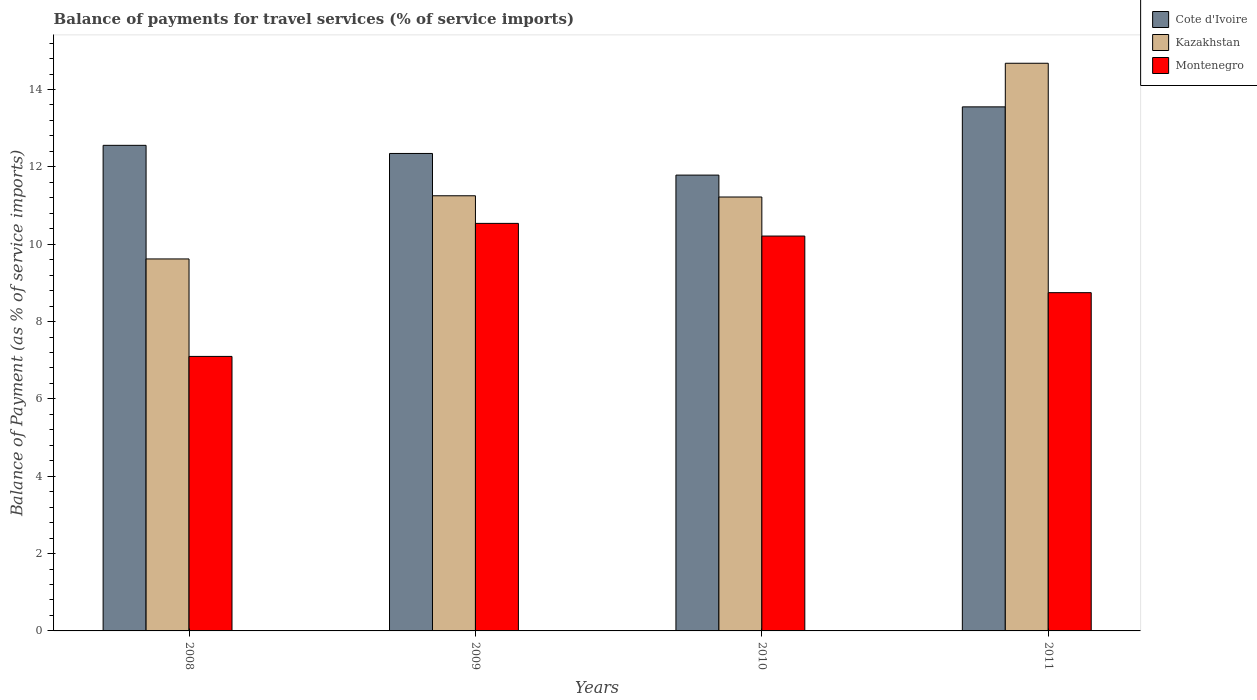How many different coloured bars are there?
Ensure brevity in your answer.  3. How many groups of bars are there?
Your answer should be compact. 4. Are the number of bars on each tick of the X-axis equal?
Keep it short and to the point. Yes. How many bars are there on the 1st tick from the right?
Ensure brevity in your answer.  3. What is the label of the 4th group of bars from the left?
Ensure brevity in your answer.  2011. In how many cases, is the number of bars for a given year not equal to the number of legend labels?
Give a very brief answer. 0. What is the balance of payments for travel services in Montenegro in 2008?
Offer a terse response. 7.1. Across all years, what is the maximum balance of payments for travel services in Cote d'Ivoire?
Offer a very short reply. 13.55. Across all years, what is the minimum balance of payments for travel services in Kazakhstan?
Keep it short and to the point. 9.62. What is the total balance of payments for travel services in Kazakhstan in the graph?
Your response must be concise. 46.77. What is the difference between the balance of payments for travel services in Montenegro in 2009 and that in 2010?
Give a very brief answer. 0.33. What is the difference between the balance of payments for travel services in Montenegro in 2008 and the balance of payments for travel services in Kazakhstan in 2011?
Make the answer very short. -7.58. What is the average balance of payments for travel services in Montenegro per year?
Your answer should be very brief. 9.15. In the year 2008, what is the difference between the balance of payments for travel services in Montenegro and balance of payments for travel services in Kazakhstan?
Your response must be concise. -2.52. What is the ratio of the balance of payments for travel services in Cote d'Ivoire in 2009 to that in 2011?
Offer a terse response. 0.91. What is the difference between the highest and the second highest balance of payments for travel services in Montenegro?
Your answer should be very brief. 0.33. What is the difference between the highest and the lowest balance of payments for travel services in Cote d'Ivoire?
Offer a very short reply. 1.76. What does the 2nd bar from the left in 2009 represents?
Offer a very short reply. Kazakhstan. What does the 3rd bar from the right in 2010 represents?
Give a very brief answer. Cote d'Ivoire. How many bars are there?
Keep it short and to the point. 12. Are all the bars in the graph horizontal?
Keep it short and to the point. No. How many years are there in the graph?
Your response must be concise. 4. What is the difference between two consecutive major ticks on the Y-axis?
Provide a short and direct response. 2. Are the values on the major ticks of Y-axis written in scientific E-notation?
Your answer should be compact. No. Does the graph contain any zero values?
Provide a short and direct response. No. Does the graph contain grids?
Give a very brief answer. No. Where does the legend appear in the graph?
Your response must be concise. Top right. How many legend labels are there?
Offer a very short reply. 3. How are the legend labels stacked?
Ensure brevity in your answer.  Vertical. What is the title of the graph?
Give a very brief answer. Balance of payments for travel services (% of service imports). What is the label or title of the X-axis?
Make the answer very short. Years. What is the label or title of the Y-axis?
Offer a very short reply. Balance of Payment (as % of service imports). What is the Balance of Payment (as % of service imports) in Cote d'Ivoire in 2008?
Offer a very short reply. 12.56. What is the Balance of Payment (as % of service imports) of Kazakhstan in 2008?
Ensure brevity in your answer.  9.62. What is the Balance of Payment (as % of service imports) in Montenegro in 2008?
Keep it short and to the point. 7.1. What is the Balance of Payment (as % of service imports) in Cote d'Ivoire in 2009?
Keep it short and to the point. 12.35. What is the Balance of Payment (as % of service imports) in Kazakhstan in 2009?
Make the answer very short. 11.25. What is the Balance of Payment (as % of service imports) in Montenegro in 2009?
Your response must be concise. 10.54. What is the Balance of Payment (as % of service imports) in Cote d'Ivoire in 2010?
Your answer should be very brief. 11.79. What is the Balance of Payment (as % of service imports) of Kazakhstan in 2010?
Provide a short and direct response. 11.22. What is the Balance of Payment (as % of service imports) in Montenegro in 2010?
Your answer should be compact. 10.21. What is the Balance of Payment (as % of service imports) in Cote d'Ivoire in 2011?
Offer a very short reply. 13.55. What is the Balance of Payment (as % of service imports) in Kazakhstan in 2011?
Offer a very short reply. 14.68. What is the Balance of Payment (as % of service imports) of Montenegro in 2011?
Your response must be concise. 8.75. Across all years, what is the maximum Balance of Payment (as % of service imports) in Cote d'Ivoire?
Make the answer very short. 13.55. Across all years, what is the maximum Balance of Payment (as % of service imports) of Kazakhstan?
Give a very brief answer. 14.68. Across all years, what is the maximum Balance of Payment (as % of service imports) of Montenegro?
Your answer should be very brief. 10.54. Across all years, what is the minimum Balance of Payment (as % of service imports) of Cote d'Ivoire?
Ensure brevity in your answer.  11.79. Across all years, what is the minimum Balance of Payment (as % of service imports) of Kazakhstan?
Provide a short and direct response. 9.62. Across all years, what is the minimum Balance of Payment (as % of service imports) in Montenegro?
Give a very brief answer. 7.1. What is the total Balance of Payment (as % of service imports) of Cote d'Ivoire in the graph?
Your response must be concise. 50.24. What is the total Balance of Payment (as % of service imports) of Kazakhstan in the graph?
Offer a terse response. 46.77. What is the total Balance of Payment (as % of service imports) in Montenegro in the graph?
Give a very brief answer. 36.59. What is the difference between the Balance of Payment (as % of service imports) in Cote d'Ivoire in 2008 and that in 2009?
Ensure brevity in your answer.  0.21. What is the difference between the Balance of Payment (as % of service imports) of Kazakhstan in 2008 and that in 2009?
Offer a very short reply. -1.63. What is the difference between the Balance of Payment (as % of service imports) of Montenegro in 2008 and that in 2009?
Give a very brief answer. -3.44. What is the difference between the Balance of Payment (as % of service imports) in Cote d'Ivoire in 2008 and that in 2010?
Your response must be concise. 0.77. What is the difference between the Balance of Payment (as % of service imports) in Kazakhstan in 2008 and that in 2010?
Give a very brief answer. -1.6. What is the difference between the Balance of Payment (as % of service imports) of Montenegro in 2008 and that in 2010?
Provide a succinct answer. -3.11. What is the difference between the Balance of Payment (as % of service imports) in Cote d'Ivoire in 2008 and that in 2011?
Offer a terse response. -0.99. What is the difference between the Balance of Payment (as % of service imports) of Kazakhstan in 2008 and that in 2011?
Your response must be concise. -5.06. What is the difference between the Balance of Payment (as % of service imports) in Montenegro in 2008 and that in 2011?
Offer a terse response. -1.65. What is the difference between the Balance of Payment (as % of service imports) in Cote d'Ivoire in 2009 and that in 2010?
Offer a terse response. 0.56. What is the difference between the Balance of Payment (as % of service imports) in Kazakhstan in 2009 and that in 2010?
Offer a terse response. 0.03. What is the difference between the Balance of Payment (as % of service imports) in Montenegro in 2009 and that in 2010?
Your answer should be compact. 0.33. What is the difference between the Balance of Payment (as % of service imports) in Cote d'Ivoire in 2009 and that in 2011?
Ensure brevity in your answer.  -1.2. What is the difference between the Balance of Payment (as % of service imports) in Kazakhstan in 2009 and that in 2011?
Keep it short and to the point. -3.43. What is the difference between the Balance of Payment (as % of service imports) in Montenegro in 2009 and that in 2011?
Your response must be concise. 1.79. What is the difference between the Balance of Payment (as % of service imports) of Cote d'Ivoire in 2010 and that in 2011?
Offer a very short reply. -1.76. What is the difference between the Balance of Payment (as % of service imports) of Kazakhstan in 2010 and that in 2011?
Provide a short and direct response. -3.46. What is the difference between the Balance of Payment (as % of service imports) of Montenegro in 2010 and that in 2011?
Ensure brevity in your answer.  1.46. What is the difference between the Balance of Payment (as % of service imports) in Cote d'Ivoire in 2008 and the Balance of Payment (as % of service imports) in Kazakhstan in 2009?
Your answer should be compact. 1.3. What is the difference between the Balance of Payment (as % of service imports) of Cote d'Ivoire in 2008 and the Balance of Payment (as % of service imports) of Montenegro in 2009?
Provide a short and direct response. 2.02. What is the difference between the Balance of Payment (as % of service imports) of Kazakhstan in 2008 and the Balance of Payment (as % of service imports) of Montenegro in 2009?
Ensure brevity in your answer.  -0.92. What is the difference between the Balance of Payment (as % of service imports) of Cote d'Ivoire in 2008 and the Balance of Payment (as % of service imports) of Kazakhstan in 2010?
Ensure brevity in your answer.  1.34. What is the difference between the Balance of Payment (as % of service imports) of Cote d'Ivoire in 2008 and the Balance of Payment (as % of service imports) of Montenegro in 2010?
Offer a terse response. 2.35. What is the difference between the Balance of Payment (as % of service imports) of Kazakhstan in 2008 and the Balance of Payment (as % of service imports) of Montenegro in 2010?
Make the answer very short. -0.59. What is the difference between the Balance of Payment (as % of service imports) of Cote d'Ivoire in 2008 and the Balance of Payment (as % of service imports) of Kazakhstan in 2011?
Provide a succinct answer. -2.12. What is the difference between the Balance of Payment (as % of service imports) of Cote d'Ivoire in 2008 and the Balance of Payment (as % of service imports) of Montenegro in 2011?
Provide a short and direct response. 3.81. What is the difference between the Balance of Payment (as % of service imports) of Kazakhstan in 2008 and the Balance of Payment (as % of service imports) of Montenegro in 2011?
Your answer should be compact. 0.87. What is the difference between the Balance of Payment (as % of service imports) of Cote d'Ivoire in 2009 and the Balance of Payment (as % of service imports) of Kazakhstan in 2010?
Offer a very short reply. 1.13. What is the difference between the Balance of Payment (as % of service imports) of Cote d'Ivoire in 2009 and the Balance of Payment (as % of service imports) of Montenegro in 2010?
Ensure brevity in your answer.  2.14. What is the difference between the Balance of Payment (as % of service imports) in Kazakhstan in 2009 and the Balance of Payment (as % of service imports) in Montenegro in 2010?
Your answer should be compact. 1.04. What is the difference between the Balance of Payment (as % of service imports) of Cote d'Ivoire in 2009 and the Balance of Payment (as % of service imports) of Kazakhstan in 2011?
Your answer should be very brief. -2.33. What is the difference between the Balance of Payment (as % of service imports) of Cote d'Ivoire in 2009 and the Balance of Payment (as % of service imports) of Montenegro in 2011?
Your answer should be very brief. 3.6. What is the difference between the Balance of Payment (as % of service imports) of Kazakhstan in 2009 and the Balance of Payment (as % of service imports) of Montenegro in 2011?
Offer a terse response. 2.51. What is the difference between the Balance of Payment (as % of service imports) of Cote d'Ivoire in 2010 and the Balance of Payment (as % of service imports) of Kazakhstan in 2011?
Provide a succinct answer. -2.89. What is the difference between the Balance of Payment (as % of service imports) of Cote d'Ivoire in 2010 and the Balance of Payment (as % of service imports) of Montenegro in 2011?
Offer a terse response. 3.04. What is the difference between the Balance of Payment (as % of service imports) in Kazakhstan in 2010 and the Balance of Payment (as % of service imports) in Montenegro in 2011?
Offer a very short reply. 2.47. What is the average Balance of Payment (as % of service imports) of Cote d'Ivoire per year?
Your response must be concise. 12.56. What is the average Balance of Payment (as % of service imports) in Kazakhstan per year?
Keep it short and to the point. 11.69. What is the average Balance of Payment (as % of service imports) of Montenegro per year?
Offer a terse response. 9.15. In the year 2008, what is the difference between the Balance of Payment (as % of service imports) of Cote d'Ivoire and Balance of Payment (as % of service imports) of Kazakhstan?
Offer a terse response. 2.94. In the year 2008, what is the difference between the Balance of Payment (as % of service imports) in Cote d'Ivoire and Balance of Payment (as % of service imports) in Montenegro?
Give a very brief answer. 5.46. In the year 2008, what is the difference between the Balance of Payment (as % of service imports) of Kazakhstan and Balance of Payment (as % of service imports) of Montenegro?
Give a very brief answer. 2.52. In the year 2009, what is the difference between the Balance of Payment (as % of service imports) in Cote d'Ivoire and Balance of Payment (as % of service imports) in Kazakhstan?
Provide a succinct answer. 1.09. In the year 2009, what is the difference between the Balance of Payment (as % of service imports) of Cote d'Ivoire and Balance of Payment (as % of service imports) of Montenegro?
Your response must be concise. 1.81. In the year 2009, what is the difference between the Balance of Payment (as % of service imports) in Kazakhstan and Balance of Payment (as % of service imports) in Montenegro?
Provide a short and direct response. 0.71. In the year 2010, what is the difference between the Balance of Payment (as % of service imports) of Cote d'Ivoire and Balance of Payment (as % of service imports) of Kazakhstan?
Make the answer very short. 0.57. In the year 2010, what is the difference between the Balance of Payment (as % of service imports) in Cote d'Ivoire and Balance of Payment (as % of service imports) in Montenegro?
Provide a succinct answer. 1.58. In the year 2010, what is the difference between the Balance of Payment (as % of service imports) of Kazakhstan and Balance of Payment (as % of service imports) of Montenegro?
Keep it short and to the point. 1.01. In the year 2011, what is the difference between the Balance of Payment (as % of service imports) in Cote d'Ivoire and Balance of Payment (as % of service imports) in Kazakhstan?
Offer a very short reply. -1.13. In the year 2011, what is the difference between the Balance of Payment (as % of service imports) in Cote d'Ivoire and Balance of Payment (as % of service imports) in Montenegro?
Give a very brief answer. 4.8. In the year 2011, what is the difference between the Balance of Payment (as % of service imports) of Kazakhstan and Balance of Payment (as % of service imports) of Montenegro?
Your answer should be compact. 5.93. What is the ratio of the Balance of Payment (as % of service imports) of Kazakhstan in 2008 to that in 2009?
Your response must be concise. 0.85. What is the ratio of the Balance of Payment (as % of service imports) in Montenegro in 2008 to that in 2009?
Keep it short and to the point. 0.67. What is the ratio of the Balance of Payment (as % of service imports) in Cote d'Ivoire in 2008 to that in 2010?
Give a very brief answer. 1.07. What is the ratio of the Balance of Payment (as % of service imports) in Kazakhstan in 2008 to that in 2010?
Make the answer very short. 0.86. What is the ratio of the Balance of Payment (as % of service imports) of Montenegro in 2008 to that in 2010?
Provide a succinct answer. 0.7. What is the ratio of the Balance of Payment (as % of service imports) of Cote d'Ivoire in 2008 to that in 2011?
Your answer should be very brief. 0.93. What is the ratio of the Balance of Payment (as % of service imports) of Kazakhstan in 2008 to that in 2011?
Provide a succinct answer. 0.66. What is the ratio of the Balance of Payment (as % of service imports) of Montenegro in 2008 to that in 2011?
Keep it short and to the point. 0.81. What is the ratio of the Balance of Payment (as % of service imports) of Cote d'Ivoire in 2009 to that in 2010?
Ensure brevity in your answer.  1.05. What is the ratio of the Balance of Payment (as % of service imports) in Montenegro in 2009 to that in 2010?
Your answer should be very brief. 1.03. What is the ratio of the Balance of Payment (as % of service imports) of Cote d'Ivoire in 2009 to that in 2011?
Make the answer very short. 0.91. What is the ratio of the Balance of Payment (as % of service imports) of Kazakhstan in 2009 to that in 2011?
Make the answer very short. 0.77. What is the ratio of the Balance of Payment (as % of service imports) in Montenegro in 2009 to that in 2011?
Provide a short and direct response. 1.2. What is the ratio of the Balance of Payment (as % of service imports) of Cote d'Ivoire in 2010 to that in 2011?
Give a very brief answer. 0.87. What is the ratio of the Balance of Payment (as % of service imports) in Kazakhstan in 2010 to that in 2011?
Your answer should be compact. 0.76. What is the ratio of the Balance of Payment (as % of service imports) in Montenegro in 2010 to that in 2011?
Provide a succinct answer. 1.17. What is the difference between the highest and the second highest Balance of Payment (as % of service imports) of Kazakhstan?
Your answer should be compact. 3.43. What is the difference between the highest and the second highest Balance of Payment (as % of service imports) of Montenegro?
Your answer should be compact. 0.33. What is the difference between the highest and the lowest Balance of Payment (as % of service imports) in Cote d'Ivoire?
Provide a succinct answer. 1.76. What is the difference between the highest and the lowest Balance of Payment (as % of service imports) in Kazakhstan?
Ensure brevity in your answer.  5.06. What is the difference between the highest and the lowest Balance of Payment (as % of service imports) in Montenegro?
Offer a very short reply. 3.44. 